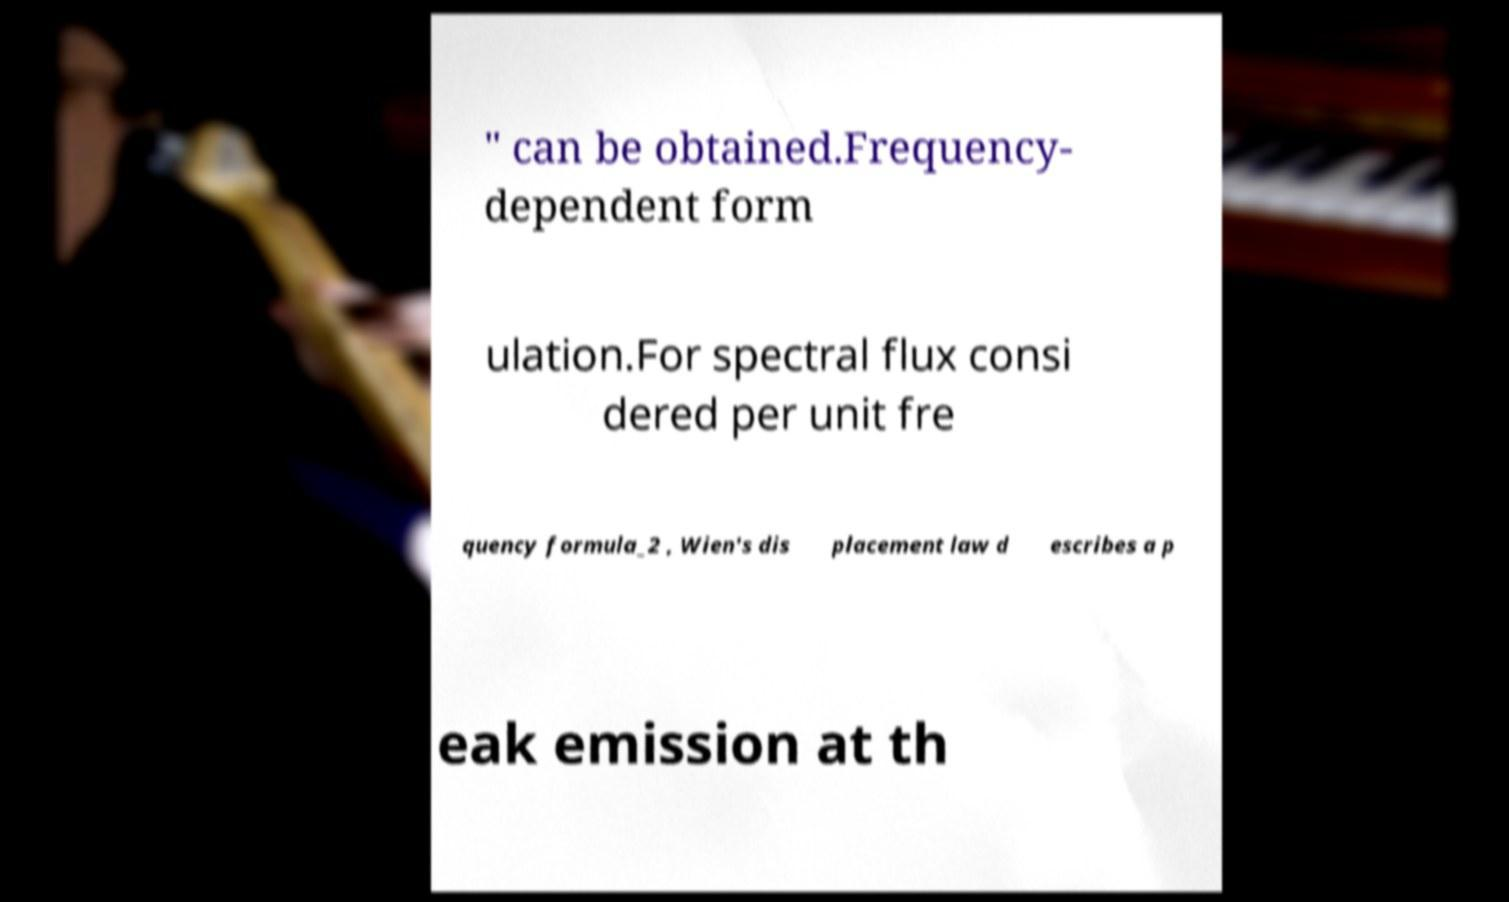Please read and relay the text visible in this image. What does it say? " can be obtained.Frequency- dependent form ulation.For spectral flux consi dered per unit fre quency formula_2 , Wien's dis placement law d escribes a p eak emission at th 